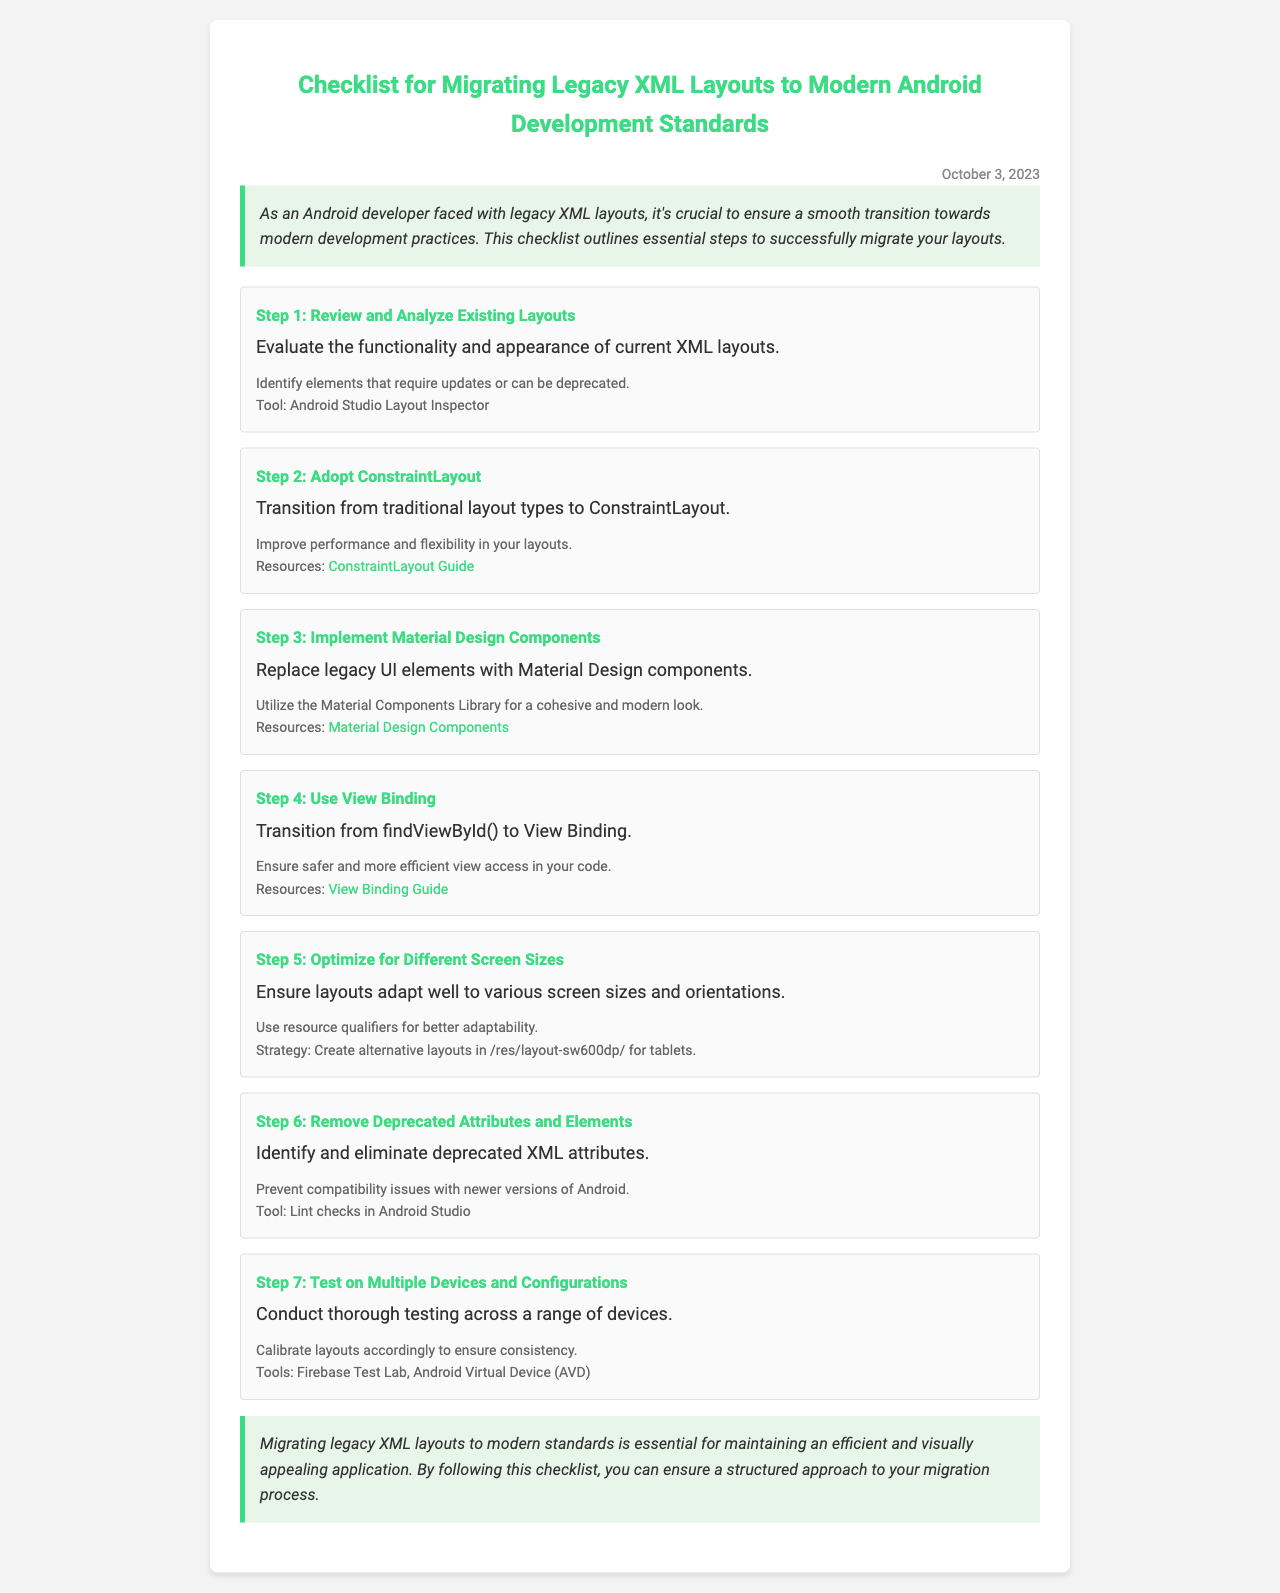What is the title of the document? The title of the document appears prominently at the top, stating the purpose of the document.
Answer: Checklist for Migrating Legacy XML Layouts to Modern Android Development Standards What is the date mentioned in the document? The date is located at the top right of the document, indicating when it was created or updated.
Answer: October 3, 2023 What is the first step in the checklist? The first item in the checklist outlines the initial action to take for the migration process.
Answer: Review and Analyze Existing Layouts How many steps are included in the checklist? The total number of steps is indicated by the number of checklist items listed.
Answer: Seven What tool is suggested for checking deprecated attributes? A specific tool for identifying deprecated XML attributes is provided in one of the checklist items.
Answer: Lint checks in Android Studio Which layout type should be adopted according to the checklist? The document specifies a particular layout type recommended for modern Android development.
Answer: ConstraintLayout What is the strategy for optimizing layouts for different screen sizes? The checklist mentions a specific strategy for accommodating various device configurations.
Answer: Create alternative layouts in /res/layout-sw600dp/ for tablets What does the conclusion emphasize about migrating layouts? The last section underscores the importance of the migration process as discussed in the checklist.
Answer: Maintaining an efficient and visually appealing application 